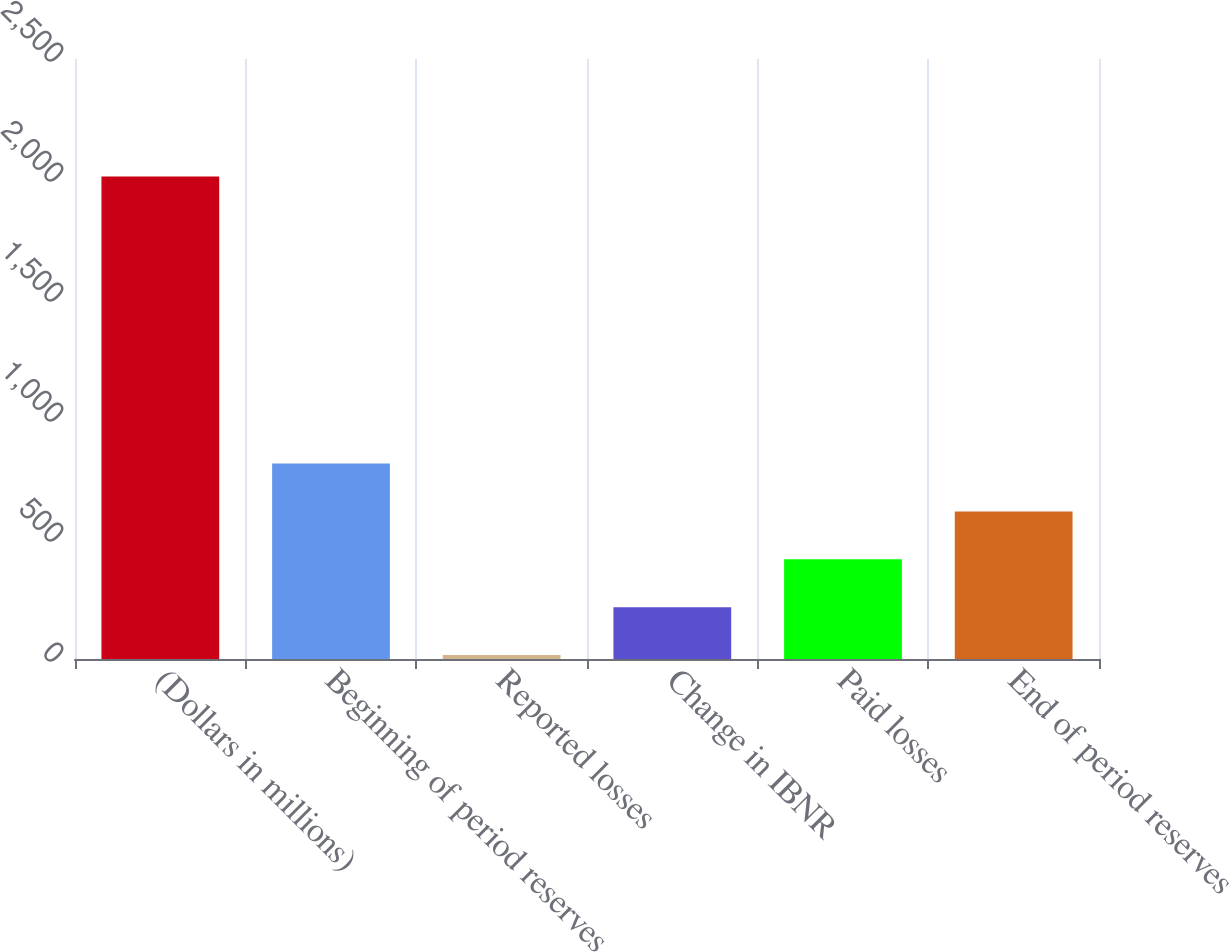<chart> <loc_0><loc_0><loc_500><loc_500><bar_chart><fcel>(Dollars in millions)<fcel>Beginning of period reserves<fcel>Reported losses<fcel>Change in IBNR<fcel>Paid losses<fcel>End of period reserves<nl><fcel>2010<fcel>814.08<fcel>16.8<fcel>216.12<fcel>415.44<fcel>614.76<nl></chart> 